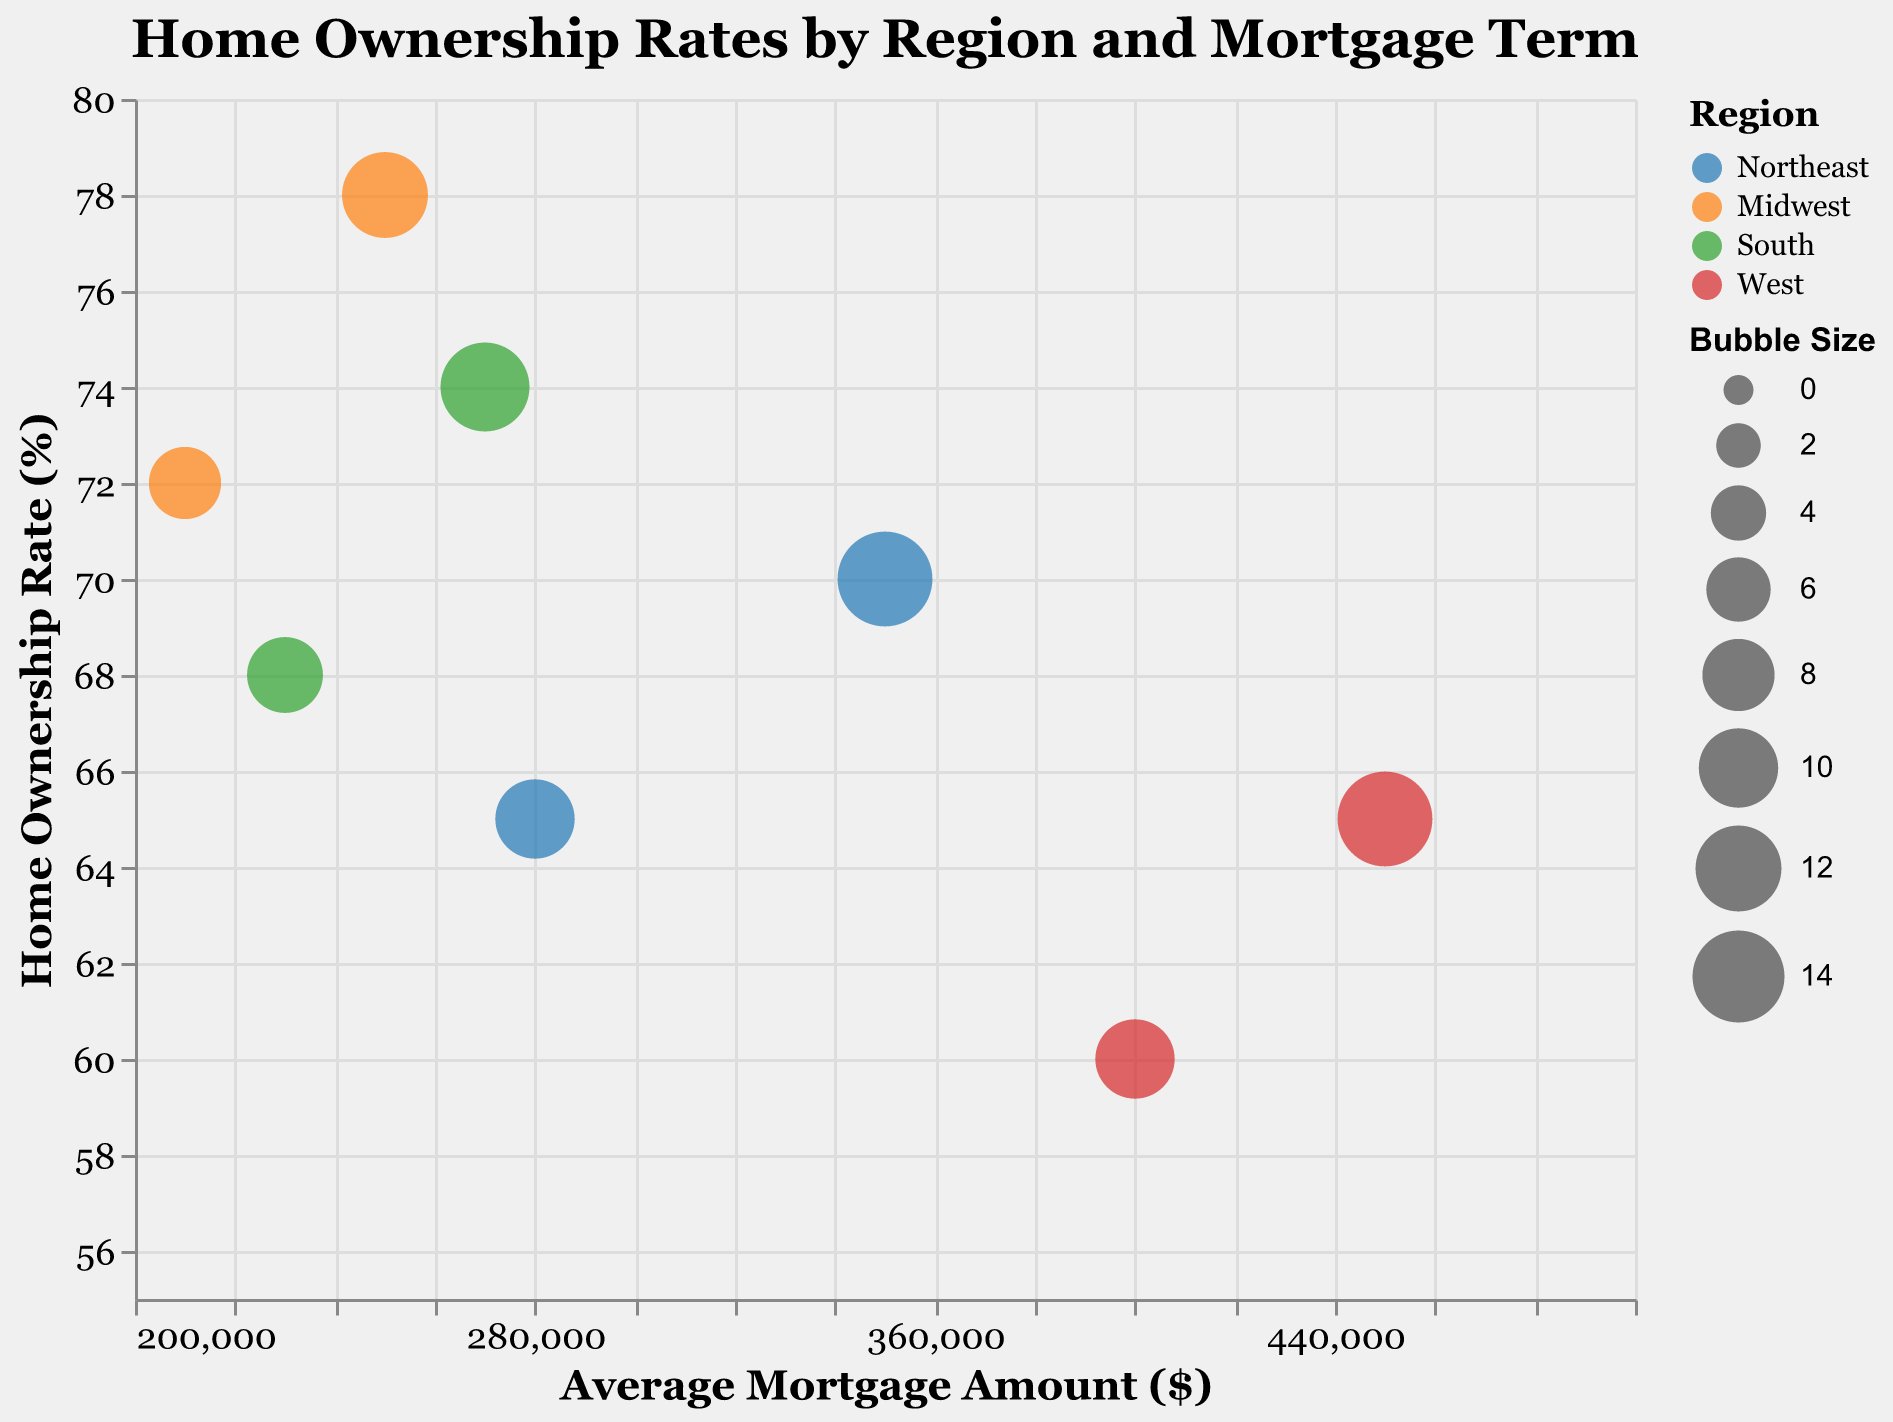What is the title of the chart? The title is located at the top of the chart and is clearly written in bold Georgia font.
Answer: Home Ownership Rates by Region and Mortgage Term How many regions are represented in the chart? The chart legend shows four different colors, each corresponding to a different region: Northeast, Midwest, South, and West.
Answer: Four Which region has the highest home ownership rate at a 30-year mortgage term? The home ownership rate for each region with a 30-year mortgage term can be found by identifying the square-shaped bubbles and checking the "Home Ownership Rate (%)" value on the y-axis. The Midwest has the highest rate of 78%.
Answer: Midwest Which bubble color represents the South region, and what is the shape of its bubbles? The legend shows that the South region is represented in green color and its bubbles are either circles or squares, depending on the mortgage term length.
Answer: Green, circles and squares What is the home ownership rate for the West region with a 15-year mortgage term? By looking at the blue-colored circle that corresponds to the West region and has an "Average Mortgage Amount ($)" around $400,000, the "Home Ownership Rate (%)" is at 60% on the y-axis.
Answer: 60% What is the difference in average mortgage amount between the Northeast and the South for a 30-year mortgage term? The average mortgage amount for the Northeast region with a 30-year term is $350,000, while for the South region it is $270,000. The difference is $350,000 - $270,000.
Answer: $80,000 Which form of mortgage term shows higher home ownership rates in general? By comparing the heights of both circle and square-shaped bubbles, higher rates tend to correspond to square-shaped bubbles, indicating that 30-year mortgages have higher home ownership rates in general.
Answer: 30-year What is the average mortgage amount in the Midwest region? The Midwest region shows two values for average mortgage amounts: $210,000 for a 15-year term and $250,000 for a 30-year term. Calculating the average: ($210,000 + $250,000) / 2.
Answer: $230,000 How does home ownership rate relate to average mortgage amount in the West region? Observing the chart, as the average mortgage amount increases from $400,000 to $450,000, the home ownership rate also increases from 60% to 65%, indicating a positive relationship within the West region.
Answer: Positive relationship What is the size of the bubble for the South region with a 15-year mortgage term? The legend indicates "Bubble Size" and "Region." For the South with a 15-year term, looking at the green circle, the size indicated in the data table is 9.
Answer: 9 